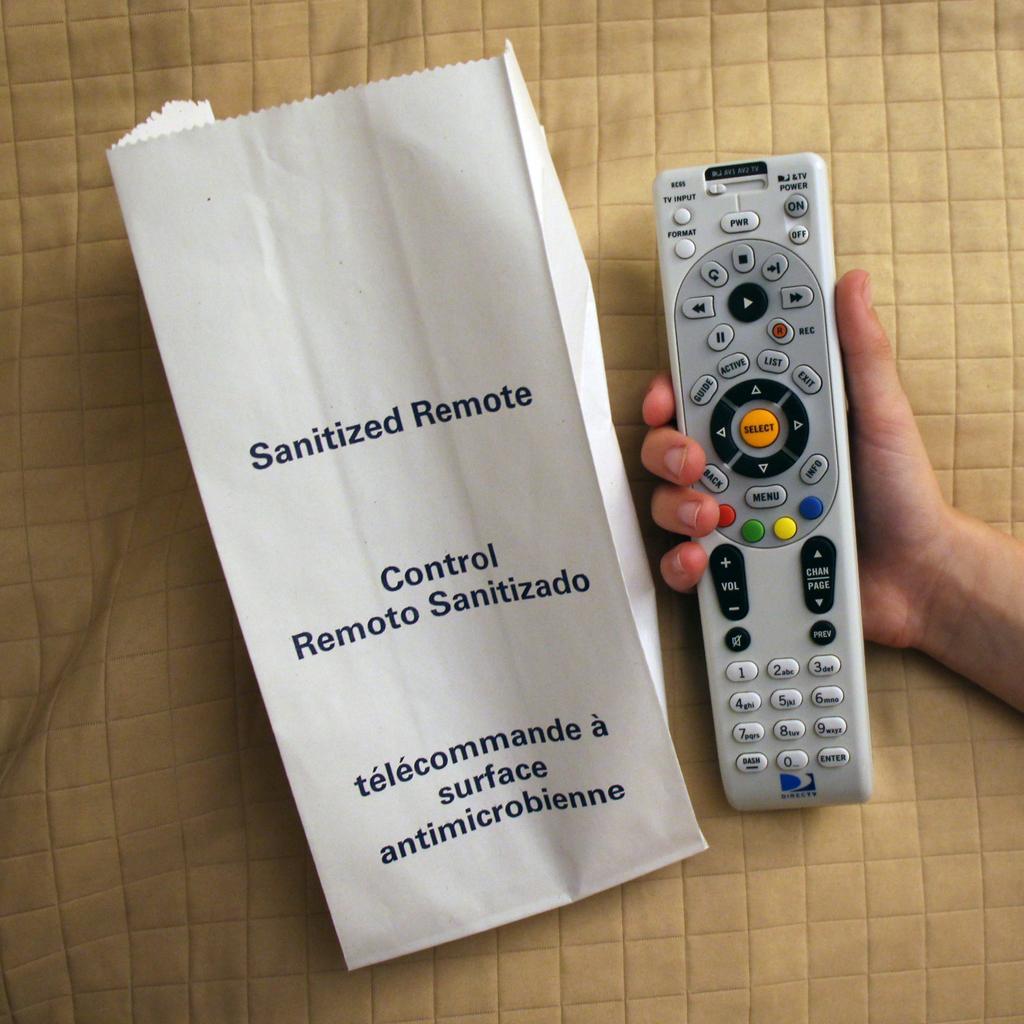What kind of remote is this?
Ensure brevity in your answer.  Sanitized. What features does the remote have?
Give a very brief answer. Sanitized. 